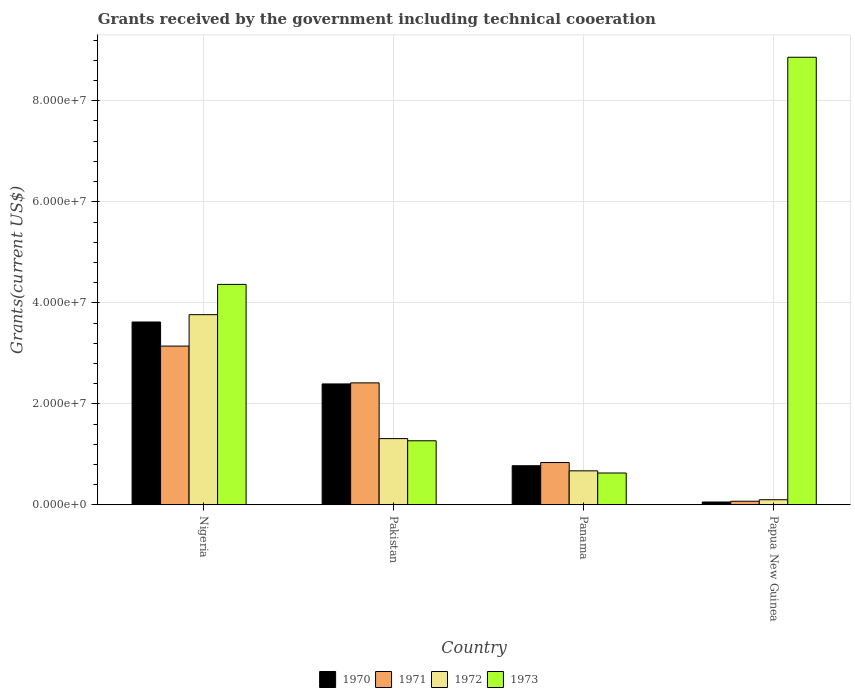How many groups of bars are there?
Offer a terse response. 4. Are the number of bars on each tick of the X-axis equal?
Offer a terse response. Yes. How many bars are there on the 3rd tick from the left?
Your answer should be compact. 4. How many bars are there on the 3rd tick from the right?
Offer a very short reply. 4. What is the total grants received by the government in 1971 in Nigeria?
Give a very brief answer. 3.14e+07. Across all countries, what is the maximum total grants received by the government in 1973?
Your response must be concise. 8.86e+07. Across all countries, what is the minimum total grants received by the government in 1971?
Your answer should be compact. 7.30e+05. In which country was the total grants received by the government in 1973 maximum?
Offer a terse response. Papua New Guinea. In which country was the total grants received by the government in 1973 minimum?
Keep it short and to the point. Panama. What is the total total grants received by the government in 1970 in the graph?
Offer a terse response. 6.85e+07. What is the difference between the total grants received by the government in 1970 in Pakistan and that in Papua New Guinea?
Provide a succinct answer. 2.34e+07. What is the difference between the total grants received by the government in 1973 in Panama and the total grants received by the government in 1972 in Papua New Guinea?
Keep it short and to the point. 5.29e+06. What is the average total grants received by the government in 1972 per country?
Your answer should be very brief. 1.46e+07. What is the difference between the total grants received by the government of/in 1972 and total grants received by the government of/in 1970 in Nigeria?
Offer a terse response. 1.45e+06. What is the ratio of the total grants received by the government in 1970 in Panama to that in Papua New Guinea?
Ensure brevity in your answer.  13.38. Is the total grants received by the government in 1973 in Pakistan less than that in Panama?
Offer a terse response. No. Is the difference between the total grants received by the government in 1972 in Nigeria and Panama greater than the difference between the total grants received by the government in 1970 in Nigeria and Panama?
Provide a succinct answer. Yes. What is the difference between the highest and the second highest total grants received by the government in 1972?
Ensure brevity in your answer.  2.45e+07. What is the difference between the highest and the lowest total grants received by the government in 1970?
Offer a terse response. 3.56e+07. Is the sum of the total grants received by the government in 1971 in Nigeria and Papua New Guinea greater than the maximum total grants received by the government in 1973 across all countries?
Your answer should be compact. No. Is it the case that in every country, the sum of the total grants received by the government in 1970 and total grants received by the government in 1973 is greater than the sum of total grants received by the government in 1971 and total grants received by the government in 1972?
Provide a succinct answer. No. What does the 2nd bar from the left in Pakistan represents?
Ensure brevity in your answer.  1971. Is it the case that in every country, the sum of the total grants received by the government in 1970 and total grants received by the government in 1972 is greater than the total grants received by the government in 1973?
Your answer should be compact. No. How many bars are there?
Offer a terse response. 16. Are all the bars in the graph horizontal?
Your answer should be very brief. No. What is the difference between two consecutive major ticks on the Y-axis?
Your answer should be very brief. 2.00e+07. Are the values on the major ticks of Y-axis written in scientific E-notation?
Offer a terse response. Yes. Does the graph contain grids?
Provide a succinct answer. Yes. How many legend labels are there?
Keep it short and to the point. 4. How are the legend labels stacked?
Provide a short and direct response. Horizontal. What is the title of the graph?
Provide a short and direct response. Grants received by the government including technical cooeration. Does "1980" appear as one of the legend labels in the graph?
Offer a terse response. No. What is the label or title of the X-axis?
Offer a very short reply. Country. What is the label or title of the Y-axis?
Make the answer very short. Grants(current US$). What is the Grants(current US$) of 1970 in Nigeria?
Your answer should be very brief. 3.62e+07. What is the Grants(current US$) of 1971 in Nigeria?
Your response must be concise. 3.14e+07. What is the Grants(current US$) of 1972 in Nigeria?
Provide a succinct answer. 3.77e+07. What is the Grants(current US$) of 1973 in Nigeria?
Provide a short and direct response. 4.36e+07. What is the Grants(current US$) in 1970 in Pakistan?
Give a very brief answer. 2.40e+07. What is the Grants(current US$) in 1971 in Pakistan?
Keep it short and to the point. 2.42e+07. What is the Grants(current US$) in 1972 in Pakistan?
Provide a short and direct response. 1.31e+07. What is the Grants(current US$) of 1973 in Pakistan?
Provide a succinct answer. 1.27e+07. What is the Grants(current US$) in 1970 in Panama?
Keep it short and to the point. 7.76e+06. What is the Grants(current US$) of 1971 in Panama?
Provide a short and direct response. 8.39e+06. What is the Grants(current US$) of 1972 in Panama?
Make the answer very short. 6.75e+06. What is the Grants(current US$) in 1973 in Panama?
Your response must be concise. 6.32e+06. What is the Grants(current US$) in 1970 in Papua New Guinea?
Ensure brevity in your answer.  5.80e+05. What is the Grants(current US$) of 1971 in Papua New Guinea?
Provide a short and direct response. 7.30e+05. What is the Grants(current US$) in 1972 in Papua New Guinea?
Provide a short and direct response. 1.03e+06. What is the Grants(current US$) in 1973 in Papua New Guinea?
Your answer should be compact. 8.86e+07. Across all countries, what is the maximum Grants(current US$) of 1970?
Offer a terse response. 3.62e+07. Across all countries, what is the maximum Grants(current US$) in 1971?
Give a very brief answer. 3.14e+07. Across all countries, what is the maximum Grants(current US$) in 1972?
Provide a short and direct response. 3.77e+07. Across all countries, what is the maximum Grants(current US$) of 1973?
Keep it short and to the point. 8.86e+07. Across all countries, what is the minimum Grants(current US$) of 1970?
Offer a terse response. 5.80e+05. Across all countries, what is the minimum Grants(current US$) of 1971?
Offer a very short reply. 7.30e+05. Across all countries, what is the minimum Grants(current US$) of 1972?
Offer a very short reply. 1.03e+06. Across all countries, what is the minimum Grants(current US$) in 1973?
Your response must be concise. 6.32e+06. What is the total Grants(current US$) of 1970 in the graph?
Provide a short and direct response. 6.85e+07. What is the total Grants(current US$) of 1971 in the graph?
Offer a very short reply. 6.47e+07. What is the total Grants(current US$) in 1972 in the graph?
Provide a short and direct response. 5.86e+07. What is the total Grants(current US$) in 1973 in the graph?
Your answer should be very brief. 1.51e+08. What is the difference between the Grants(current US$) in 1970 in Nigeria and that in Pakistan?
Ensure brevity in your answer.  1.23e+07. What is the difference between the Grants(current US$) of 1971 in Nigeria and that in Pakistan?
Make the answer very short. 7.28e+06. What is the difference between the Grants(current US$) of 1972 in Nigeria and that in Pakistan?
Make the answer very short. 2.45e+07. What is the difference between the Grants(current US$) in 1973 in Nigeria and that in Pakistan?
Keep it short and to the point. 3.10e+07. What is the difference between the Grants(current US$) of 1970 in Nigeria and that in Panama?
Give a very brief answer. 2.84e+07. What is the difference between the Grants(current US$) of 1971 in Nigeria and that in Panama?
Offer a terse response. 2.30e+07. What is the difference between the Grants(current US$) of 1972 in Nigeria and that in Panama?
Provide a short and direct response. 3.09e+07. What is the difference between the Grants(current US$) of 1973 in Nigeria and that in Panama?
Offer a very short reply. 3.73e+07. What is the difference between the Grants(current US$) of 1970 in Nigeria and that in Papua New Guinea?
Your answer should be compact. 3.56e+07. What is the difference between the Grants(current US$) in 1971 in Nigeria and that in Papua New Guinea?
Your answer should be compact. 3.07e+07. What is the difference between the Grants(current US$) in 1972 in Nigeria and that in Papua New Guinea?
Provide a short and direct response. 3.66e+07. What is the difference between the Grants(current US$) of 1973 in Nigeria and that in Papua New Guinea?
Provide a short and direct response. -4.50e+07. What is the difference between the Grants(current US$) of 1970 in Pakistan and that in Panama?
Offer a very short reply. 1.62e+07. What is the difference between the Grants(current US$) of 1971 in Pakistan and that in Panama?
Offer a very short reply. 1.58e+07. What is the difference between the Grants(current US$) in 1972 in Pakistan and that in Panama?
Offer a very short reply. 6.38e+06. What is the difference between the Grants(current US$) in 1973 in Pakistan and that in Panama?
Provide a short and direct response. 6.38e+06. What is the difference between the Grants(current US$) of 1970 in Pakistan and that in Papua New Guinea?
Make the answer very short. 2.34e+07. What is the difference between the Grants(current US$) of 1971 in Pakistan and that in Papua New Guinea?
Your answer should be very brief. 2.34e+07. What is the difference between the Grants(current US$) of 1972 in Pakistan and that in Papua New Guinea?
Give a very brief answer. 1.21e+07. What is the difference between the Grants(current US$) in 1973 in Pakistan and that in Papua New Guinea?
Your response must be concise. -7.59e+07. What is the difference between the Grants(current US$) in 1970 in Panama and that in Papua New Guinea?
Make the answer very short. 7.18e+06. What is the difference between the Grants(current US$) of 1971 in Panama and that in Papua New Guinea?
Provide a short and direct response. 7.66e+06. What is the difference between the Grants(current US$) of 1972 in Panama and that in Papua New Guinea?
Your answer should be very brief. 5.72e+06. What is the difference between the Grants(current US$) in 1973 in Panama and that in Papua New Guinea?
Keep it short and to the point. -8.23e+07. What is the difference between the Grants(current US$) in 1970 in Nigeria and the Grants(current US$) in 1971 in Pakistan?
Provide a succinct answer. 1.20e+07. What is the difference between the Grants(current US$) in 1970 in Nigeria and the Grants(current US$) in 1972 in Pakistan?
Ensure brevity in your answer.  2.31e+07. What is the difference between the Grants(current US$) in 1970 in Nigeria and the Grants(current US$) in 1973 in Pakistan?
Your response must be concise. 2.35e+07. What is the difference between the Grants(current US$) of 1971 in Nigeria and the Grants(current US$) of 1972 in Pakistan?
Offer a terse response. 1.83e+07. What is the difference between the Grants(current US$) in 1971 in Nigeria and the Grants(current US$) in 1973 in Pakistan?
Make the answer very short. 1.87e+07. What is the difference between the Grants(current US$) in 1972 in Nigeria and the Grants(current US$) in 1973 in Pakistan?
Your answer should be very brief. 2.50e+07. What is the difference between the Grants(current US$) in 1970 in Nigeria and the Grants(current US$) in 1971 in Panama?
Offer a very short reply. 2.78e+07. What is the difference between the Grants(current US$) of 1970 in Nigeria and the Grants(current US$) of 1972 in Panama?
Your answer should be very brief. 2.95e+07. What is the difference between the Grants(current US$) of 1970 in Nigeria and the Grants(current US$) of 1973 in Panama?
Give a very brief answer. 2.99e+07. What is the difference between the Grants(current US$) of 1971 in Nigeria and the Grants(current US$) of 1972 in Panama?
Ensure brevity in your answer.  2.47e+07. What is the difference between the Grants(current US$) of 1971 in Nigeria and the Grants(current US$) of 1973 in Panama?
Offer a terse response. 2.51e+07. What is the difference between the Grants(current US$) in 1972 in Nigeria and the Grants(current US$) in 1973 in Panama?
Your response must be concise. 3.13e+07. What is the difference between the Grants(current US$) in 1970 in Nigeria and the Grants(current US$) in 1971 in Papua New Guinea?
Provide a succinct answer. 3.55e+07. What is the difference between the Grants(current US$) in 1970 in Nigeria and the Grants(current US$) in 1972 in Papua New Guinea?
Ensure brevity in your answer.  3.52e+07. What is the difference between the Grants(current US$) in 1970 in Nigeria and the Grants(current US$) in 1973 in Papua New Guinea?
Provide a succinct answer. -5.24e+07. What is the difference between the Grants(current US$) of 1971 in Nigeria and the Grants(current US$) of 1972 in Papua New Guinea?
Provide a short and direct response. 3.04e+07. What is the difference between the Grants(current US$) in 1971 in Nigeria and the Grants(current US$) in 1973 in Papua New Guinea?
Ensure brevity in your answer.  -5.72e+07. What is the difference between the Grants(current US$) of 1972 in Nigeria and the Grants(current US$) of 1973 in Papua New Guinea?
Ensure brevity in your answer.  -5.10e+07. What is the difference between the Grants(current US$) of 1970 in Pakistan and the Grants(current US$) of 1971 in Panama?
Provide a short and direct response. 1.56e+07. What is the difference between the Grants(current US$) in 1970 in Pakistan and the Grants(current US$) in 1972 in Panama?
Make the answer very short. 1.72e+07. What is the difference between the Grants(current US$) of 1970 in Pakistan and the Grants(current US$) of 1973 in Panama?
Your answer should be compact. 1.76e+07. What is the difference between the Grants(current US$) in 1971 in Pakistan and the Grants(current US$) in 1972 in Panama?
Make the answer very short. 1.74e+07. What is the difference between the Grants(current US$) of 1971 in Pakistan and the Grants(current US$) of 1973 in Panama?
Provide a short and direct response. 1.78e+07. What is the difference between the Grants(current US$) of 1972 in Pakistan and the Grants(current US$) of 1973 in Panama?
Give a very brief answer. 6.81e+06. What is the difference between the Grants(current US$) of 1970 in Pakistan and the Grants(current US$) of 1971 in Papua New Guinea?
Ensure brevity in your answer.  2.32e+07. What is the difference between the Grants(current US$) in 1970 in Pakistan and the Grants(current US$) in 1972 in Papua New Guinea?
Ensure brevity in your answer.  2.29e+07. What is the difference between the Grants(current US$) of 1970 in Pakistan and the Grants(current US$) of 1973 in Papua New Guinea?
Provide a short and direct response. -6.47e+07. What is the difference between the Grants(current US$) in 1971 in Pakistan and the Grants(current US$) in 1972 in Papua New Guinea?
Your answer should be very brief. 2.31e+07. What is the difference between the Grants(current US$) in 1971 in Pakistan and the Grants(current US$) in 1973 in Papua New Guinea?
Your answer should be very brief. -6.44e+07. What is the difference between the Grants(current US$) of 1972 in Pakistan and the Grants(current US$) of 1973 in Papua New Guinea?
Provide a succinct answer. -7.55e+07. What is the difference between the Grants(current US$) in 1970 in Panama and the Grants(current US$) in 1971 in Papua New Guinea?
Ensure brevity in your answer.  7.03e+06. What is the difference between the Grants(current US$) of 1970 in Panama and the Grants(current US$) of 1972 in Papua New Guinea?
Make the answer very short. 6.73e+06. What is the difference between the Grants(current US$) in 1970 in Panama and the Grants(current US$) in 1973 in Papua New Guinea?
Ensure brevity in your answer.  -8.08e+07. What is the difference between the Grants(current US$) of 1971 in Panama and the Grants(current US$) of 1972 in Papua New Guinea?
Offer a very short reply. 7.36e+06. What is the difference between the Grants(current US$) in 1971 in Panama and the Grants(current US$) in 1973 in Papua New Guinea?
Ensure brevity in your answer.  -8.02e+07. What is the difference between the Grants(current US$) in 1972 in Panama and the Grants(current US$) in 1973 in Papua New Guinea?
Give a very brief answer. -8.19e+07. What is the average Grants(current US$) in 1970 per country?
Offer a terse response. 1.71e+07. What is the average Grants(current US$) in 1971 per country?
Your response must be concise. 1.62e+07. What is the average Grants(current US$) in 1972 per country?
Offer a terse response. 1.46e+07. What is the average Grants(current US$) in 1973 per country?
Your answer should be very brief. 3.78e+07. What is the difference between the Grants(current US$) in 1970 and Grants(current US$) in 1971 in Nigeria?
Keep it short and to the point. 4.77e+06. What is the difference between the Grants(current US$) of 1970 and Grants(current US$) of 1972 in Nigeria?
Make the answer very short. -1.45e+06. What is the difference between the Grants(current US$) of 1970 and Grants(current US$) of 1973 in Nigeria?
Make the answer very short. -7.44e+06. What is the difference between the Grants(current US$) of 1971 and Grants(current US$) of 1972 in Nigeria?
Offer a very short reply. -6.22e+06. What is the difference between the Grants(current US$) of 1971 and Grants(current US$) of 1973 in Nigeria?
Offer a very short reply. -1.22e+07. What is the difference between the Grants(current US$) of 1972 and Grants(current US$) of 1973 in Nigeria?
Make the answer very short. -5.99e+06. What is the difference between the Grants(current US$) of 1970 and Grants(current US$) of 1971 in Pakistan?
Provide a short and direct response. -2.10e+05. What is the difference between the Grants(current US$) of 1970 and Grants(current US$) of 1972 in Pakistan?
Provide a short and direct response. 1.08e+07. What is the difference between the Grants(current US$) in 1970 and Grants(current US$) in 1973 in Pakistan?
Give a very brief answer. 1.12e+07. What is the difference between the Grants(current US$) of 1971 and Grants(current US$) of 1972 in Pakistan?
Offer a very short reply. 1.10e+07. What is the difference between the Grants(current US$) of 1971 and Grants(current US$) of 1973 in Pakistan?
Offer a terse response. 1.15e+07. What is the difference between the Grants(current US$) of 1970 and Grants(current US$) of 1971 in Panama?
Your answer should be very brief. -6.30e+05. What is the difference between the Grants(current US$) in 1970 and Grants(current US$) in 1972 in Panama?
Your answer should be very brief. 1.01e+06. What is the difference between the Grants(current US$) in 1970 and Grants(current US$) in 1973 in Panama?
Your response must be concise. 1.44e+06. What is the difference between the Grants(current US$) of 1971 and Grants(current US$) of 1972 in Panama?
Offer a very short reply. 1.64e+06. What is the difference between the Grants(current US$) of 1971 and Grants(current US$) of 1973 in Panama?
Give a very brief answer. 2.07e+06. What is the difference between the Grants(current US$) in 1970 and Grants(current US$) in 1972 in Papua New Guinea?
Your response must be concise. -4.50e+05. What is the difference between the Grants(current US$) in 1970 and Grants(current US$) in 1973 in Papua New Guinea?
Make the answer very short. -8.80e+07. What is the difference between the Grants(current US$) of 1971 and Grants(current US$) of 1973 in Papua New Guinea?
Provide a succinct answer. -8.79e+07. What is the difference between the Grants(current US$) in 1972 and Grants(current US$) in 1973 in Papua New Guinea?
Provide a short and direct response. -8.76e+07. What is the ratio of the Grants(current US$) of 1970 in Nigeria to that in Pakistan?
Give a very brief answer. 1.51. What is the ratio of the Grants(current US$) in 1971 in Nigeria to that in Pakistan?
Ensure brevity in your answer.  1.3. What is the ratio of the Grants(current US$) in 1972 in Nigeria to that in Pakistan?
Your response must be concise. 2.87. What is the ratio of the Grants(current US$) in 1973 in Nigeria to that in Pakistan?
Your answer should be compact. 3.44. What is the ratio of the Grants(current US$) of 1970 in Nigeria to that in Panama?
Ensure brevity in your answer.  4.67. What is the ratio of the Grants(current US$) in 1971 in Nigeria to that in Panama?
Give a very brief answer. 3.75. What is the ratio of the Grants(current US$) in 1972 in Nigeria to that in Panama?
Ensure brevity in your answer.  5.58. What is the ratio of the Grants(current US$) of 1973 in Nigeria to that in Panama?
Your answer should be compact. 6.91. What is the ratio of the Grants(current US$) of 1970 in Nigeria to that in Papua New Guinea?
Your response must be concise. 62.43. What is the ratio of the Grants(current US$) in 1971 in Nigeria to that in Papua New Guinea?
Your response must be concise. 43.07. What is the ratio of the Grants(current US$) in 1972 in Nigeria to that in Papua New Guinea?
Your answer should be very brief. 36.56. What is the ratio of the Grants(current US$) in 1973 in Nigeria to that in Papua New Guinea?
Your answer should be compact. 0.49. What is the ratio of the Grants(current US$) of 1970 in Pakistan to that in Panama?
Give a very brief answer. 3.09. What is the ratio of the Grants(current US$) in 1971 in Pakistan to that in Panama?
Keep it short and to the point. 2.88. What is the ratio of the Grants(current US$) of 1972 in Pakistan to that in Panama?
Your answer should be compact. 1.95. What is the ratio of the Grants(current US$) in 1973 in Pakistan to that in Panama?
Provide a short and direct response. 2.01. What is the ratio of the Grants(current US$) in 1970 in Pakistan to that in Papua New Guinea?
Your response must be concise. 41.29. What is the ratio of the Grants(current US$) in 1971 in Pakistan to that in Papua New Guinea?
Provide a succinct answer. 33.1. What is the ratio of the Grants(current US$) of 1972 in Pakistan to that in Papua New Guinea?
Provide a short and direct response. 12.75. What is the ratio of the Grants(current US$) of 1973 in Pakistan to that in Papua New Guinea?
Your answer should be compact. 0.14. What is the ratio of the Grants(current US$) in 1970 in Panama to that in Papua New Guinea?
Keep it short and to the point. 13.38. What is the ratio of the Grants(current US$) of 1971 in Panama to that in Papua New Guinea?
Provide a short and direct response. 11.49. What is the ratio of the Grants(current US$) in 1972 in Panama to that in Papua New Guinea?
Ensure brevity in your answer.  6.55. What is the ratio of the Grants(current US$) in 1973 in Panama to that in Papua New Guinea?
Give a very brief answer. 0.07. What is the difference between the highest and the second highest Grants(current US$) in 1970?
Your response must be concise. 1.23e+07. What is the difference between the highest and the second highest Grants(current US$) of 1971?
Your answer should be compact. 7.28e+06. What is the difference between the highest and the second highest Grants(current US$) in 1972?
Give a very brief answer. 2.45e+07. What is the difference between the highest and the second highest Grants(current US$) of 1973?
Your response must be concise. 4.50e+07. What is the difference between the highest and the lowest Grants(current US$) in 1970?
Your answer should be very brief. 3.56e+07. What is the difference between the highest and the lowest Grants(current US$) in 1971?
Your response must be concise. 3.07e+07. What is the difference between the highest and the lowest Grants(current US$) of 1972?
Give a very brief answer. 3.66e+07. What is the difference between the highest and the lowest Grants(current US$) in 1973?
Your answer should be compact. 8.23e+07. 